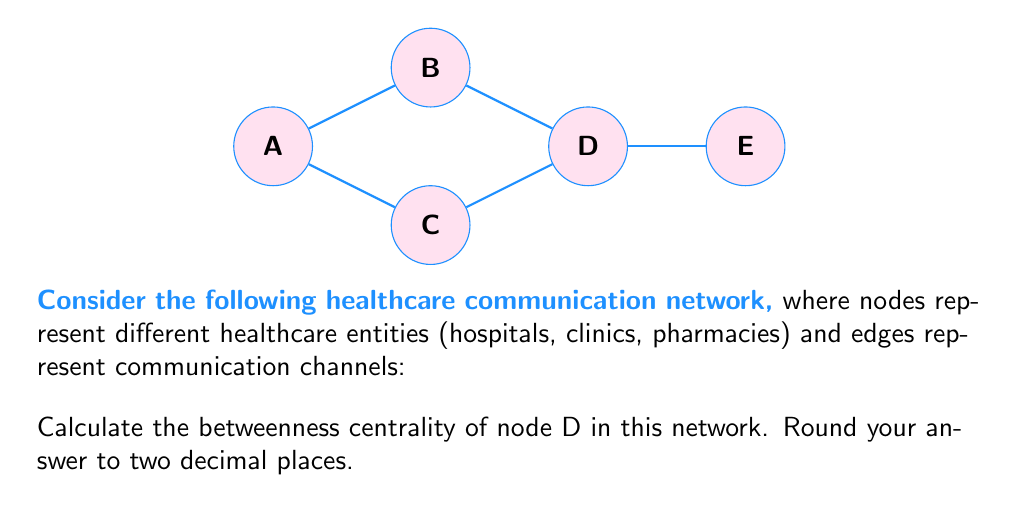Show me your answer to this math problem. To calculate the betweenness centrality of node D, we need to follow these steps:

1) First, identify all shortest paths between pairs of nodes:
   A-B, A-C, A-B-D, A-C-D, A-B-D-E
   B-D, B-D-E
   C-D, C-D-E
   D-E

2) Count the number of shortest paths that pass through node D:
   A-B-D: 1
   A-C-D: 1
   A-B-D-E: 1
   A-C-D-E: 1
   B-D: 1
   B-D-E: 1
   C-D: 1
   C-D-E: 1
   D-E: 1

3) Calculate the fraction of shortest paths that pass through D for each pair:
   A-D: 2/2 = 1
   A-E: 2/2 = 1
   B-D: 1/1 = 1
   B-E: 1/1 = 1
   C-D: 1/1 = 1
   C-E: 1/1 = 1
   D-E: 1/1 = 1

4) Sum these fractions:
   $$BC(D) = 1 + 1 + 1 + 1 + 1 + 1 + 1 = 7$$

5) Normalize by dividing by $\frac{(n-1)(n-2)}{2}$, where n is the number of nodes:
   $$BC_{normalized}(D) = \frac{7}{\frac{(5-1)(5-2)}{2}} = \frac{7}{6} \approx 1.17$$

Therefore, the betweenness centrality of node D, rounded to two decimal places, is 1.17.
Answer: 1.17 